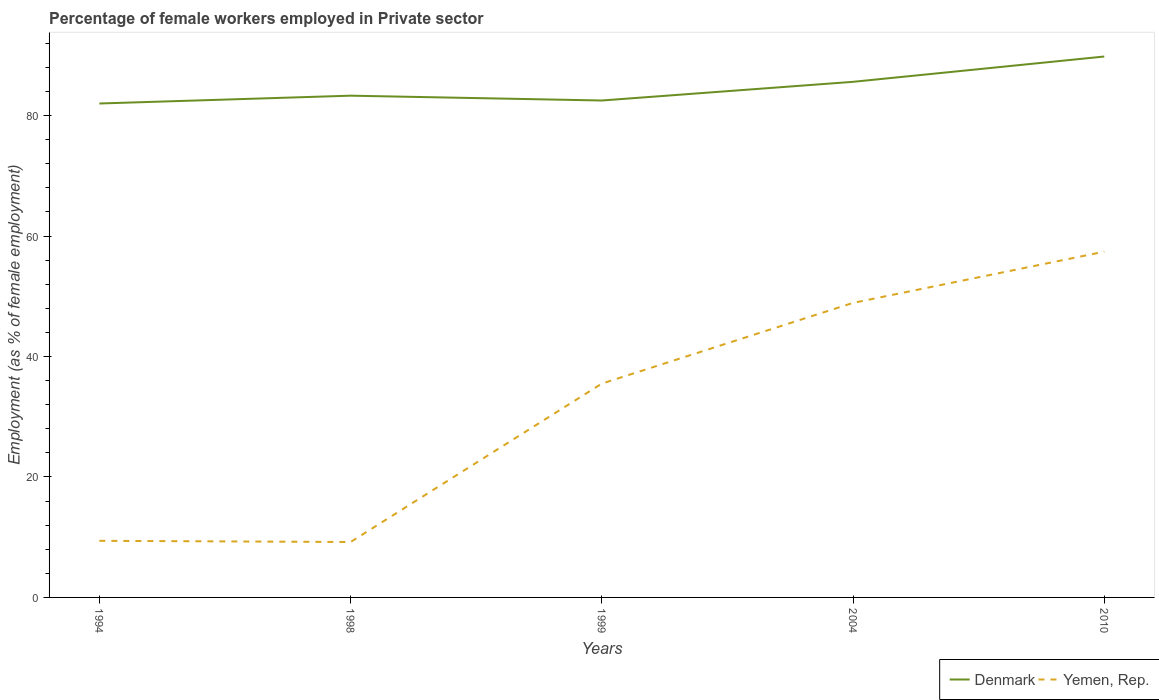How many different coloured lines are there?
Provide a short and direct response. 2. Does the line corresponding to Denmark intersect with the line corresponding to Yemen, Rep.?
Give a very brief answer. No. Across all years, what is the maximum percentage of females employed in Private sector in Yemen, Rep.?
Your answer should be compact. 9.2. In which year was the percentage of females employed in Private sector in Yemen, Rep. maximum?
Make the answer very short. 1998. What is the difference between the highest and the second highest percentage of females employed in Private sector in Yemen, Rep.?
Your response must be concise. 48.2. What is the difference between the highest and the lowest percentage of females employed in Private sector in Denmark?
Make the answer very short. 2. How many lines are there?
Your response must be concise. 2. Does the graph contain grids?
Offer a very short reply. No. How are the legend labels stacked?
Your answer should be compact. Horizontal. What is the title of the graph?
Your answer should be compact. Percentage of female workers employed in Private sector. What is the label or title of the X-axis?
Make the answer very short. Years. What is the label or title of the Y-axis?
Ensure brevity in your answer.  Employment (as % of female employment). What is the Employment (as % of female employment) in Yemen, Rep. in 1994?
Ensure brevity in your answer.  9.4. What is the Employment (as % of female employment) of Denmark in 1998?
Keep it short and to the point. 83.3. What is the Employment (as % of female employment) in Yemen, Rep. in 1998?
Your answer should be compact. 9.2. What is the Employment (as % of female employment) of Denmark in 1999?
Keep it short and to the point. 82.5. What is the Employment (as % of female employment) in Yemen, Rep. in 1999?
Offer a terse response. 35.5. What is the Employment (as % of female employment) in Denmark in 2004?
Give a very brief answer. 85.6. What is the Employment (as % of female employment) of Yemen, Rep. in 2004?
Your answer should be compact. 48.9. What is the Employment (as % of female employment) of Denmark in 2010?
Keep it short and to the point. 89.8. What is the Employment (as % of female employment) of Yemen, Rep. in 2010?
Offer a very short reply. 57.4. Across all years, what is the maximum Employment (as % of female employment) in Denmark?
Give a very brief answer. 89.8. Across all years, what is the maximum Employment (as % of female employment) of Yemen, Rep.?
Your answer should be very brief. 57.4. Across all years, what is the minimum Employment (as % of female employment) in Denmark?
Offer a terse response. 82. Across all years, what is the minimum Employment (as % of female employment) in Yemen, Rep.?
Your answer should be very brief. 9.2. What is the total Employment (as % of female employment) of Denmark in the graph?
Offer a very short reply. 423.2. What is the total Employment (as % of female employment) of Yemen, Rep. in the graph?
Your response must be concise. 160.4. What is the difference between the Employment (as % of female employment) in Denmark in 1994 and that in 1998?
Ensure brevity in your answer.  -1.3. What is the difference between the Employment (as % of female employment) of Yemen, Rep. in 1994 and that in 1999?
Make the answer very short. -26.1. What is the difference between the Employment (as % of female employment) of Denmark in 1994 and that in 2004?
Provide a short and direct response. -3.6. What is the difference between the Employment (as % of female employment) in Yemen, Rep. in 1994 and that in 2004?
Provide a succinct answer. -39.5. What is the difference between the Employment (as % of female employment) in Denmark in 1994 and that in 2010?
Offer a very short reply. -7.8. What is the difference between the Employment (as % of female employment) in Yemen, Rep. in 1994 and that in 2010?
Your answer should be very brief. -48. What is the difference between the Employment (as % of female employment) in Denmark in 1998 and that in 1999?
Offer a terse response. 0.8. What is the difference between the Employment (as % of female employment) of Yemen, Rep. in 1998 and that in 1999?
Keep it short and to the point. -26.3. What is the difference between the Employment (as % of female employment) in Yemen, Rep. in 1998 and that in 2004?
Offer a terse response. -39.7. What is the difference between the Employment (as % of female employment) in Denmark in 1998 and that in 2010?
Offer a very short reply. -6.5. What is the difference between the Employment (as % of female employment) of Yemen, Rep. in 1998 and that in 2010?
Your response must be concise. -48.2. What is the difference between the Employment (as % of female employment) of Denmark in 1999 and that in 2004?
Keep it short and to the point. -3.1. What is the difference between the Employment (as % of female employment) in Denmark in 1999 and that in 2010?
Make the answer very short. -7.3. What is the difference between the Employment (as % of female employment) in Yemen, Rep. in 1999 and that in 2010?
Offer a very short reply. -21.9. What is the difference between the Employment (as % of female employment) in Denmark in 1994 and the Employment (as % of female employment) in Yemen, Rep. in 1998?
Give a very brief answer. 72.8. What is the difference between the Employment (as % of female employment) of Denmark in 1994 and the Employment (as % of female employment) of Yemen, Rep. in 1999?
Provide a succinct answer. 46.5. What is the difference between the Employment (as % of female employment) of Denmark in 1994 and the Employment (as % of female employment) of Yemen, Rep. in 2004?
Make the answer very short. 33.1. What is the difference between the Employment (as % of female employment) in Denmark in 1994 and the Employment (as % of female employment) in Yemen, Rep. in 2010?
Your answer should be very brief. 24.6. What is the difference between the Employment (as % of female employment) in Denmark in 1998 and the Employment (as % of female employment) in Yemen, Rep. in 1999?
Make the answer very short. 47.8. What is the difference between the Employment (as % of female employment) of Denmark in 1998 and the Employment (as % of female employment) of Yemen, Rep. in 2004?
Ensure brevity in your answer.  34.4. What is the difference between the Employment (as % of female employment) of Denmark in 1998 and the Employment (as % of female employment) of Yemen, Rep. in 2010?
Keep it short and to the point. 25.9. What is the difference between the Employment (as % of female employment) of Denmark in 1999 and the Employment (as % of female employment) of Yemen, Rep. in 2004?
Ensure brevity in your answer.  33.6. What is the difference between the Employment (as % of female employment) of Denmark in 1999 and the Employment (as % of female employment) of Yemen, Rep. in 2010?
Ensure brevity in your answer.  25.1. What is the difference between the Employment (as % of female employment) in Denmark in 2004 and the Employment (as % of female employment) in Yemen, Rep. in 2010?
Give a very brief answer. 28.2. What is the average Employment (as % of female employment) in Denmark per year?
Keep it short and to the point. 84.64. What is the average Employment (as % of female employment) in Yemen, Rep. per year?
Provide a short and direct response. 32.08. In the year 1994, what is the difference between the Employment (as % of female employment) in Denmark and Employment (as % of female employment) in Yemen, Rep.?
Your answer should be compact. 72.6. In the year 1998, what is the difference between the Employment (as % of female employment) in Denmark and Employment (as % of female employment) in Yemen, Rep.?
Your answer should be compact. 74.1. In the year 2004, what is the difference between the Employment (as % of female employment) in Denmark and Employment (as % of female employment) in Yemen, Rep.?
Your response must be concise. 36.7. In the year 2010, what is the difference between the Employment (as % of female employment) in Denmark and Employment (as % of female employment) in Yemen, Rep.?
Make the answer very short. 32.4. What is the ratio of the Employment (as % of female employment) of Denmark in 1994 to that in 1998?
Offer a terse response. 0.98. What is the ratio of the Employment (as % of female employment) in Yemen, Rep. in 1994 to that in 1998?
Offer a very short reply. 1.02. What is the ratio of the Employment (as % of female employment) in Denmark in 1994 to that in 1999?
Ensure brevity in your answer.  0.99. What is the ratio of the Employment (as % of female employment) of Yemen, Rep. in 1994 to that in 1999?
Offer a terse response. 0.26. What is the ratio of the Employment (as % of female employment) in Denmark in 1994 to that in 2004?
Offer a terse response. 0.96. What is the ratio of the Employment (as % of female employment) in Yemen, Rep. in 1994 to that in 2004?
Your answer should be very brief. 0.19. What is the ratio of the Employment (as % of female employment) in Denmark in 1994 to that in 2010?
Offer a very short reply. 0.91. What is the ratio of the Employment (as % of female employment) in Yemen, Rep. in 1994 to that in 2010?
Ensure brevity in your answer.  0.16. What is the ratio of the Employment (as % of female employment) of Denmark in 1998 to that in 1999?
Make the answer very short. 1.01. What is the ratio of the Employment (as % of female employment) in Yemen, Rep. in 1998 to that in 1999?
Your answer should be compact. 0.26. What is the ratio of the Employment (as % of female employment) in Denmark in 1998 to that in 2004?
Keep it short and to the point. 0.97. What is the ratio of the Employment (as % of female employment) in Yemen, Rep. in 1998 to that in 2004?
Give a very brief answer. 0.19. What is the ratio of the Employment (as % of female employment) in Denmark in 1998 to that in 2010?
Offer a terse response. 0.93. What is the ratio of the Employment (as % of female employment) of Yemen, Rep. in 1998 to that in 2010?
Offer a very short reply. 0.16. What is the ratio of the Employment (as % of female employment) of Denmark in 1999 to that in 2004?
Give a very brief answer. 0.96. What is the ratio of the Employment (as % of female employment) of Yemen, Rep. in 1999 to that in 2004?
Keep it short and to the point. 0.73. What is the ratio of the Employment (as % of female employment) of Denmark in 1999 to that in 2010?
Provide a succinct answer. 0.92. What is the ratio of the Employment (as % of female employment) in Yemen, Rep. in 1999 to that in 2010?
Your answer should be compact. 0.62. What is the ratio of the Employment (as % of female employment) in Denmark in 2004 to that in 2010?
Make the answer very short. 0.95. What is the ratio of the Employment (as % of female employment) of Yemen, Rep. in 2004 to that in 2010?
Your answer should be compact. 0.85. What is the difference between the highest and the second highest Employment (as % of female employment) of Denmark?
Ensure brevity in your answer.  4.2. What is the difference between the highest and the lowest Employment (as % of female employment) of Yemen, Rep.?
Ensure brevity in your answer.  48.2. 